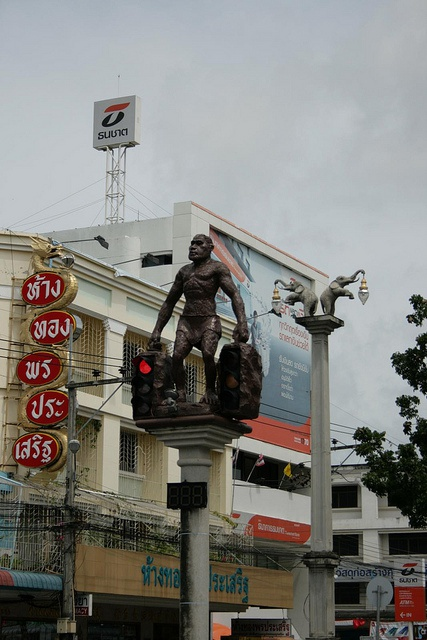Describe the objects in this image and their specific colors. I can see people in darkgray, black, and gray tones, traffic light in darkgray, black, brown, and maroon tones, and elephant in darkgray, gray, and black tones in this image. 